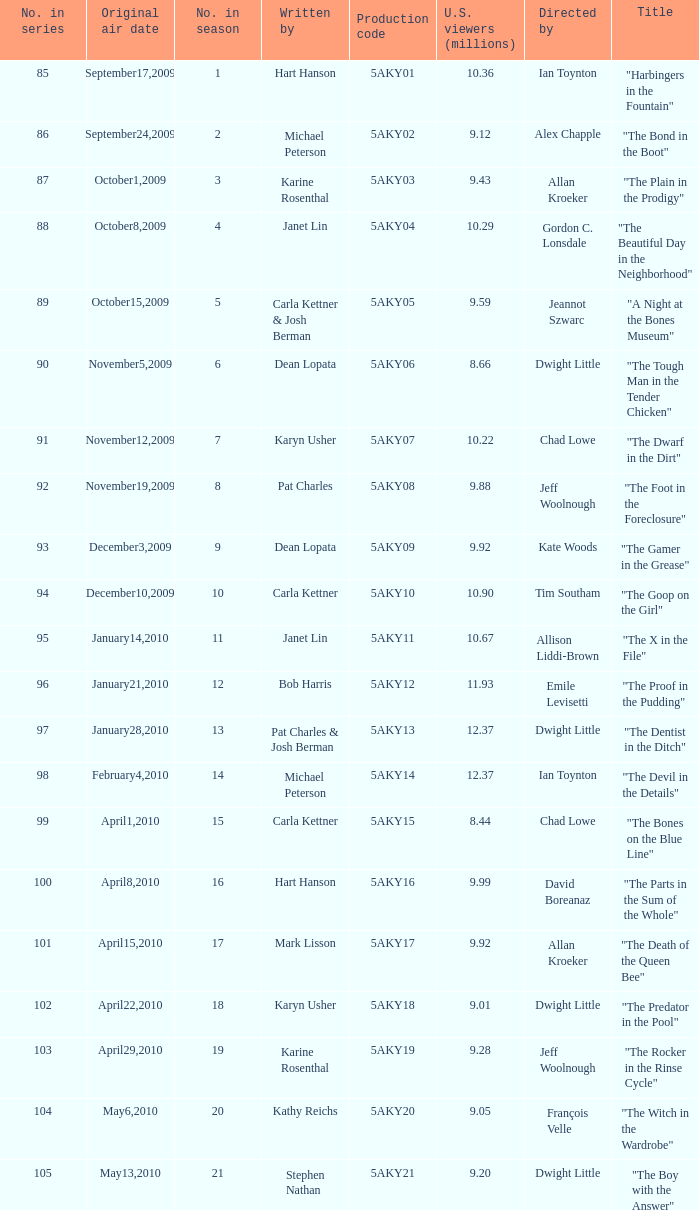Who was the writer of the episode with a production code of 5aky04? Janet Lin. 